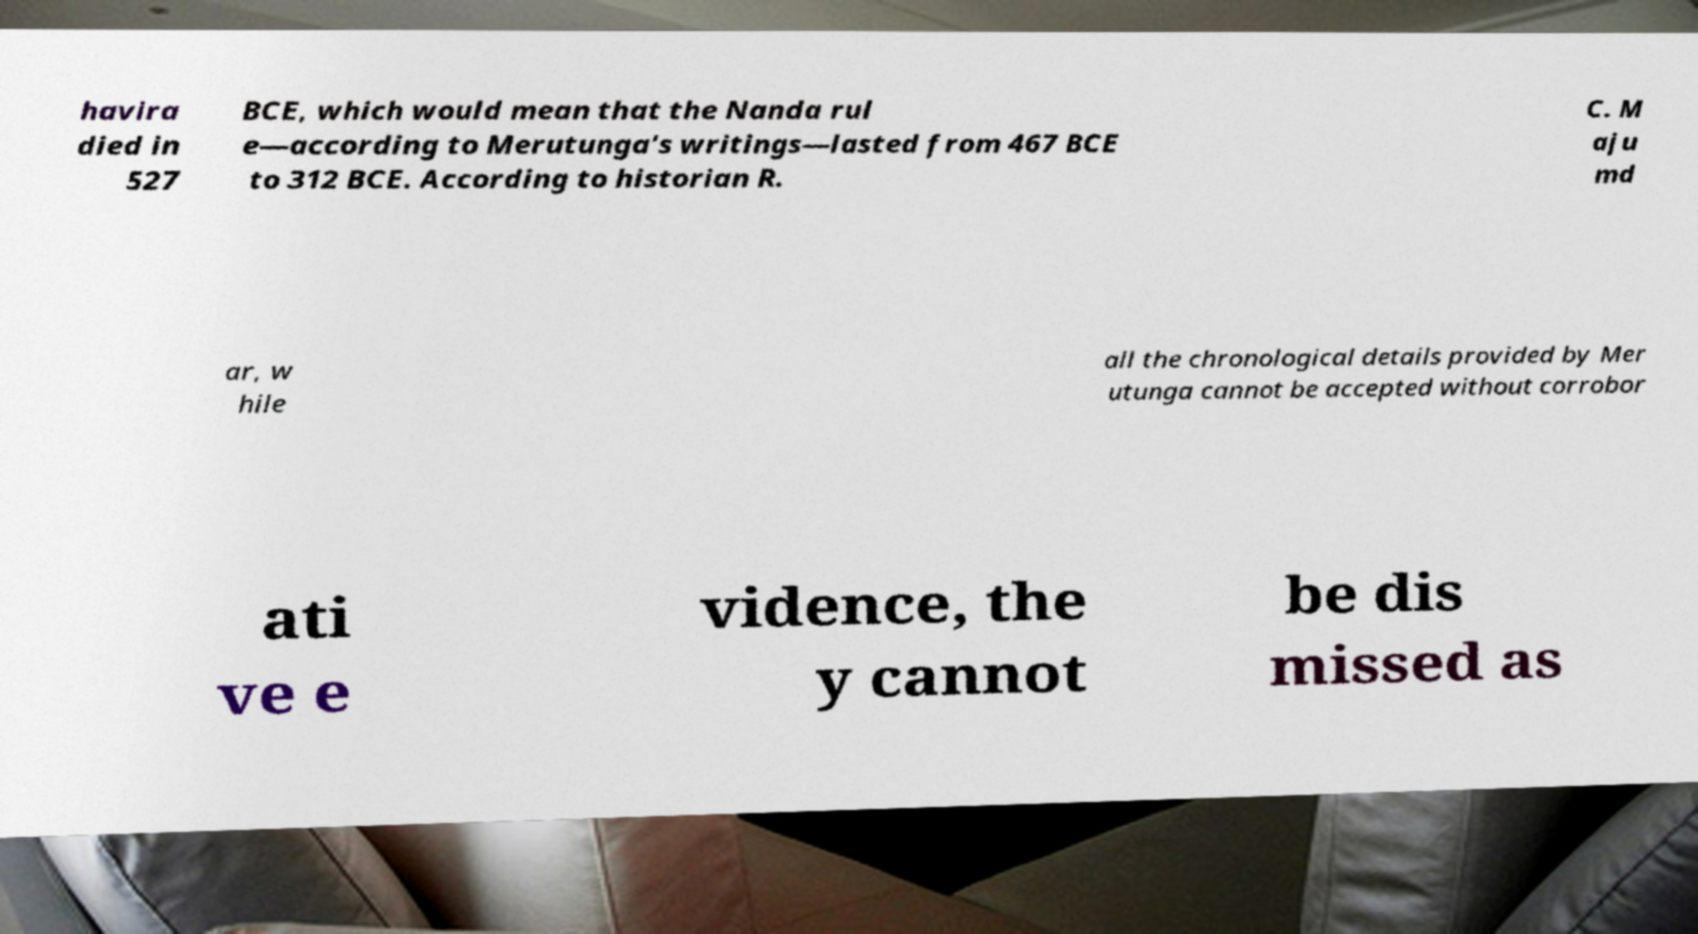I need the written content from this picture converted into text. Can you do that? havira died in 527 BCE, which would mean that the Nanda rul e—according to Merutunga's writings—lasted from 467 BCE to 312 BCE. According to historian R. C. M aju md ar, w hile all the chronological details provided by Mer utunga cannot be accepted without corrobor ati ve e vidence, the y cannot be dis missed as 